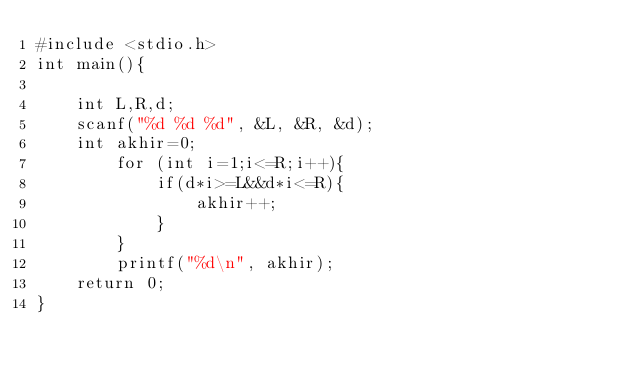<code> <loc_0><loc_0><loc_500><loc_500><_C++_>#include <stdio.h>
int main(){
	
	int L,R,d;
	scanf("%d %d %d", &L, &R, &d);
	int akhir=0;
		for (int i=1;i<=R;i++){
			if(d*i>=L&&d*i<=R){
				akhir++;
			}
		}
		printf("%d\n", akhir);
	return 0;
}</code> 